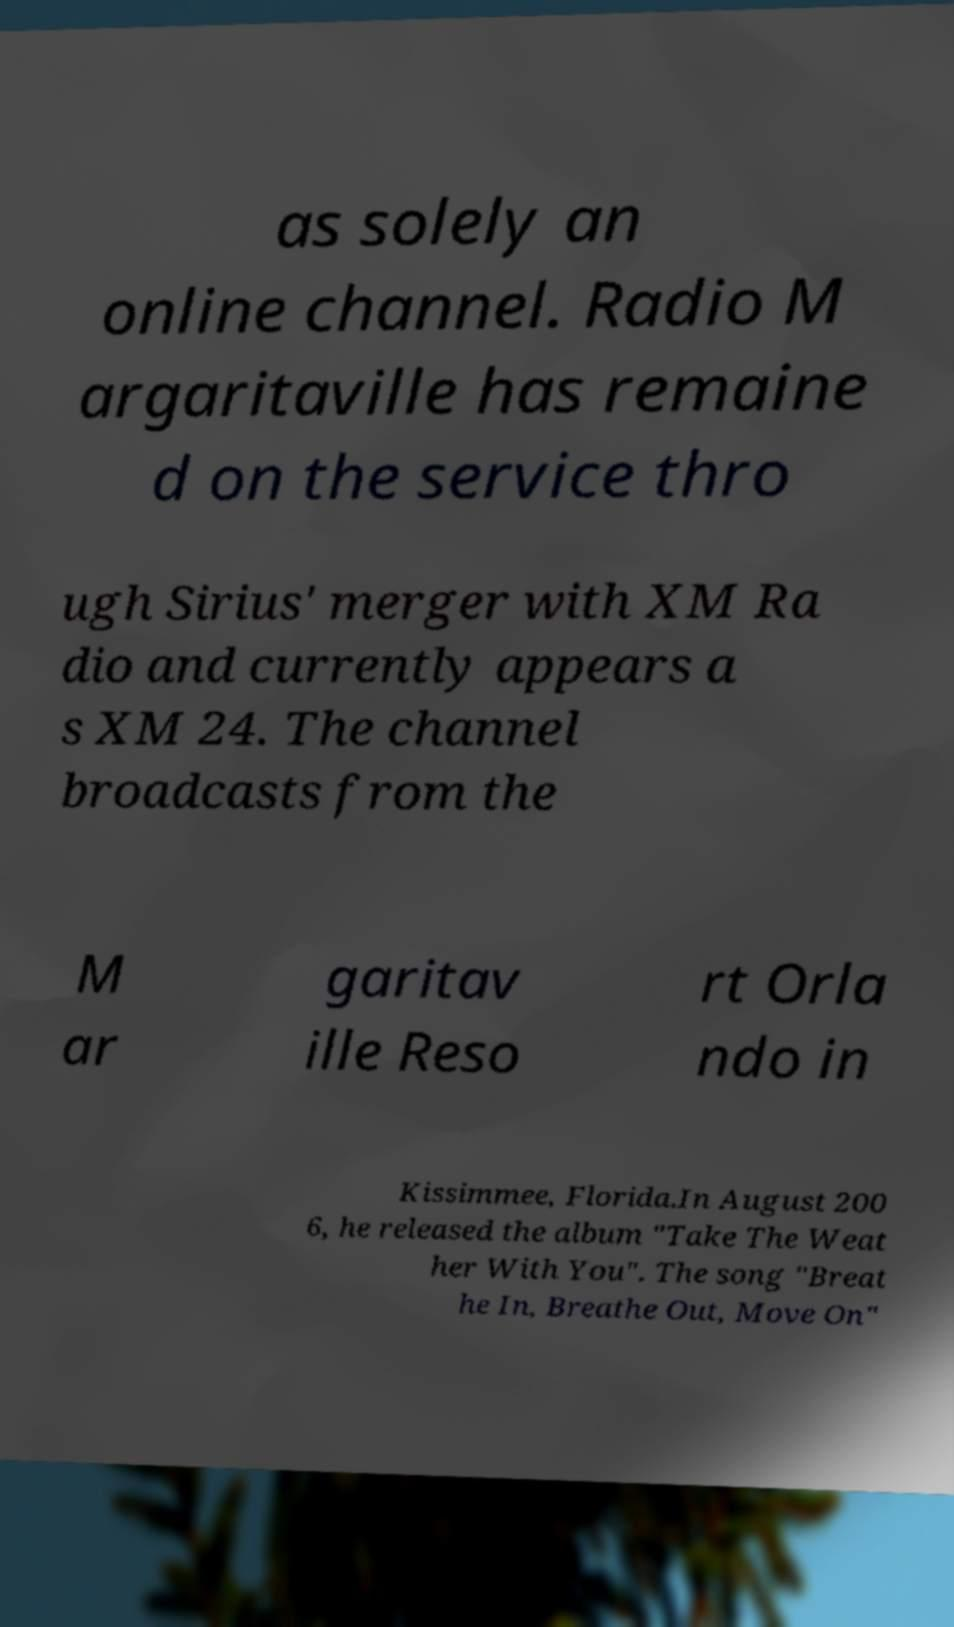What messages or text are displayed in this image? I need them in a readable, typed format. as solely an online channel. Radio M argaritaville has remaine d on the service thro ugh Sirius' merger with XM Ra dio and currently appears a s XM 24. The channel broadcasts from the M ar garitav ille Reso rt Orla ndo in Kissimmee, Florida.In August 200 6, he released the album "Take The Weat her With You". The song "Breat he In, Breathe Out, Move On" 